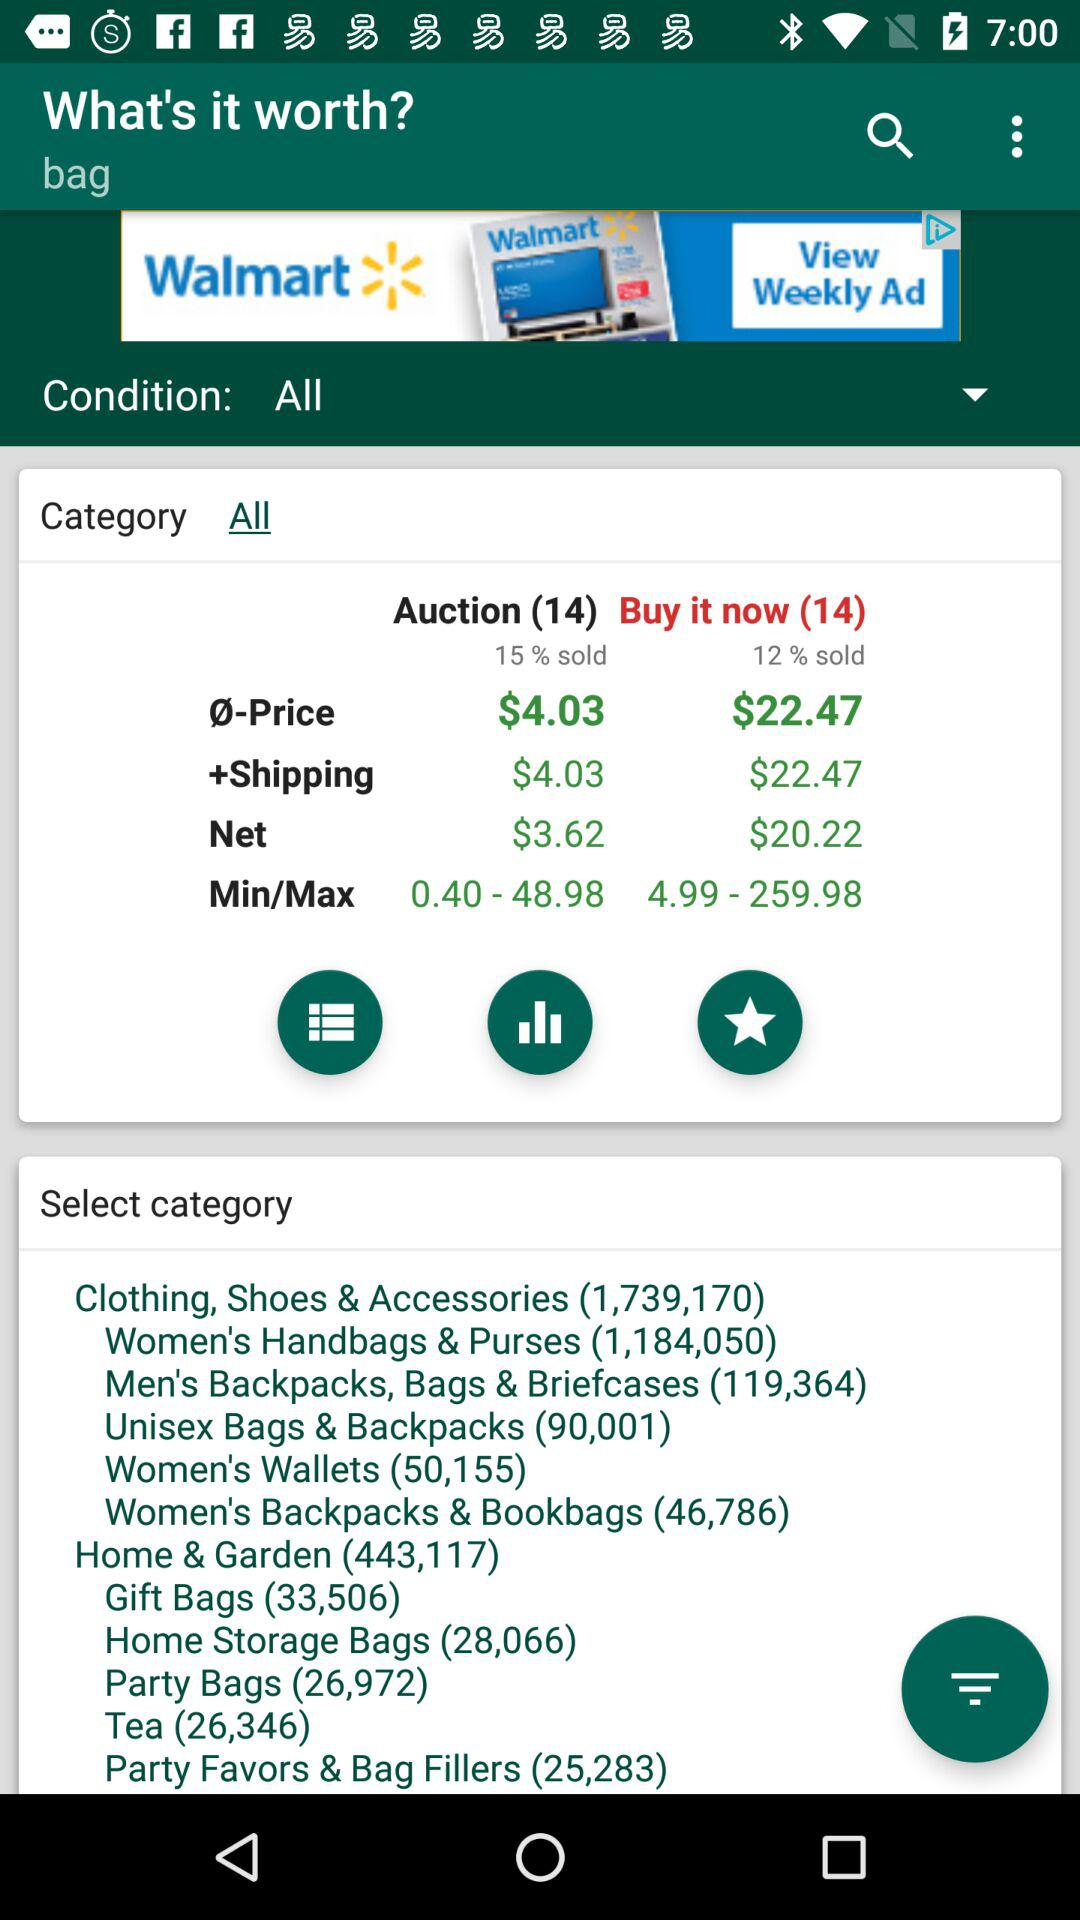What is the auction price? The auction price is $4.03. 